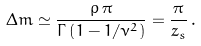<formula> <loc_0><loc_0><loc_500><loc_500>\Delta m \simeq \frac { \rho \, \pi } { \Gamma \left ( 1 - 1 / \nu ^ { 2 } \right ) } = \frac { \pi } { z _ { s } } \, .</formula> 